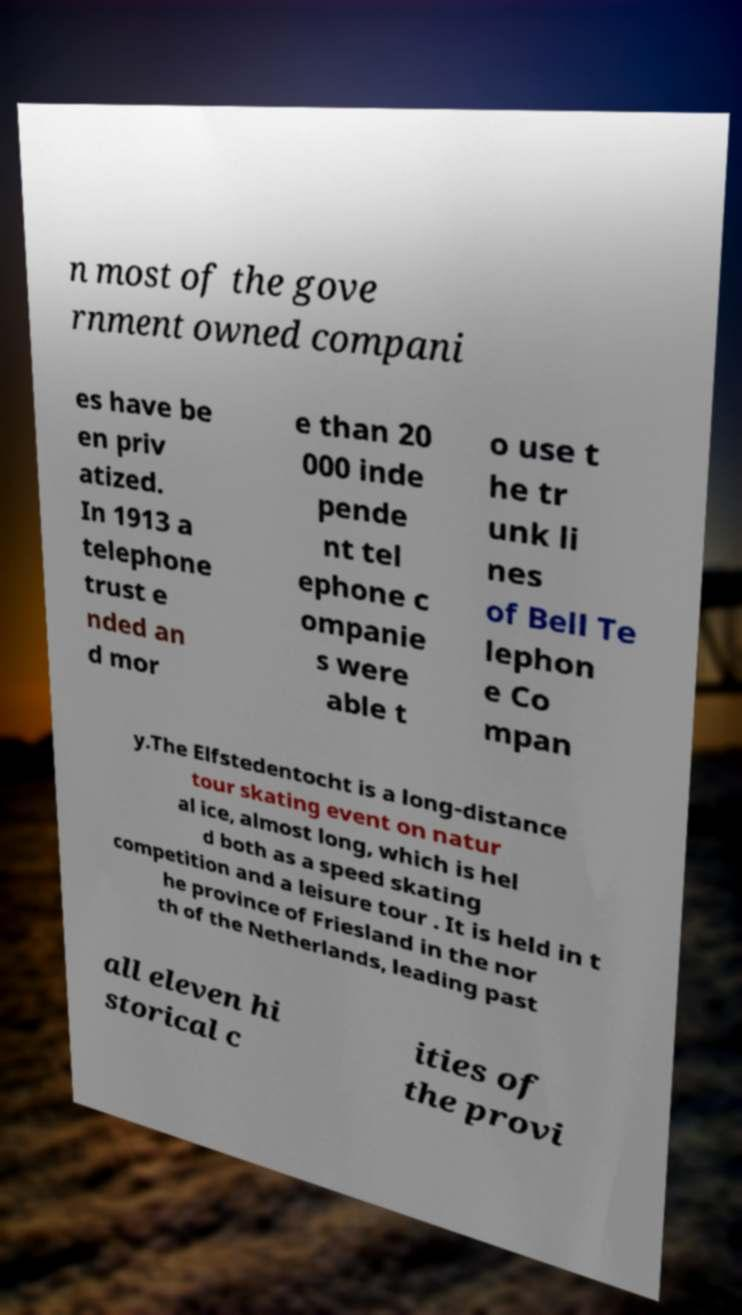Please read and relay the text visible in this image. What does it say? n most of the gove rnment owned compani es have be en priv atized. In 1913 a telephone trust e nded an d mor e than 20 000 inde pende nt tel ephone c ompanie s were able t o use t he tr unk li nes of Bell Te lephon e Co mpan y.The Elfstedentocht is a long-distance tour skating event on natur al ice, almost long, which is hel d both as a speed skating competition and a leisure tour . It is held in t he province of Friesland in the nor th of the Netherlands, leading past all eleven hi storical c ities of the provi 